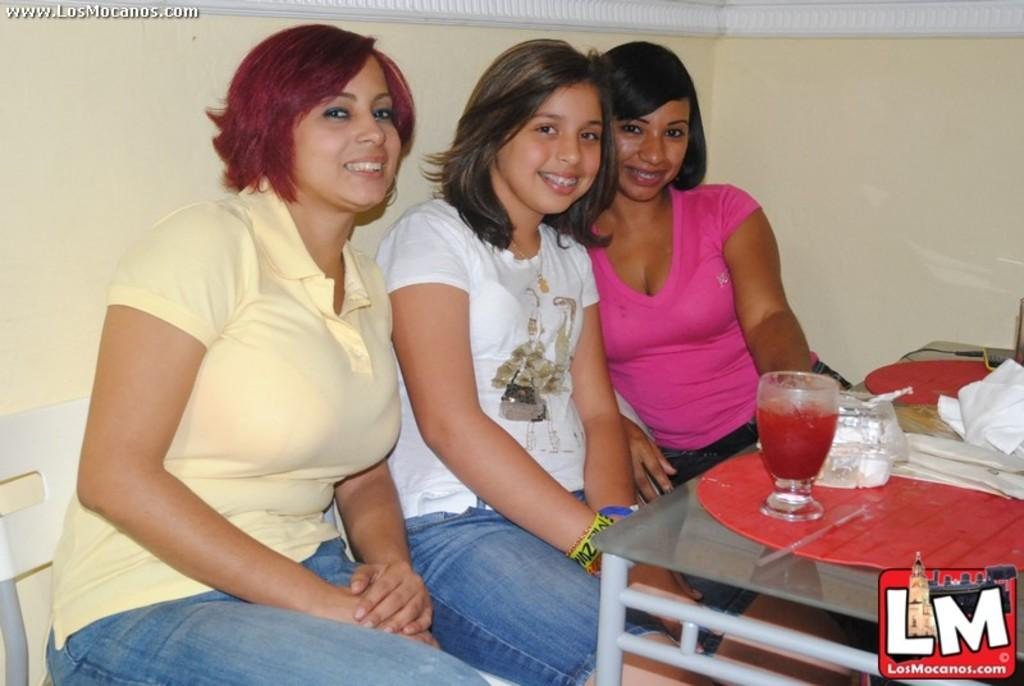How many women are in the image? There are three women in the image. What are the women doing in the image? The women are sitting. What objects can be seen on the table in the image? There is a glass and a plate on a table. What can be seen in the background of the image? There is a wall visible in the background. Can you tell me how many goats are present in the image? There are no goats present in the image. What question are the women discussing in the image? The image does not provide information about a specific question being discussed by the women. 